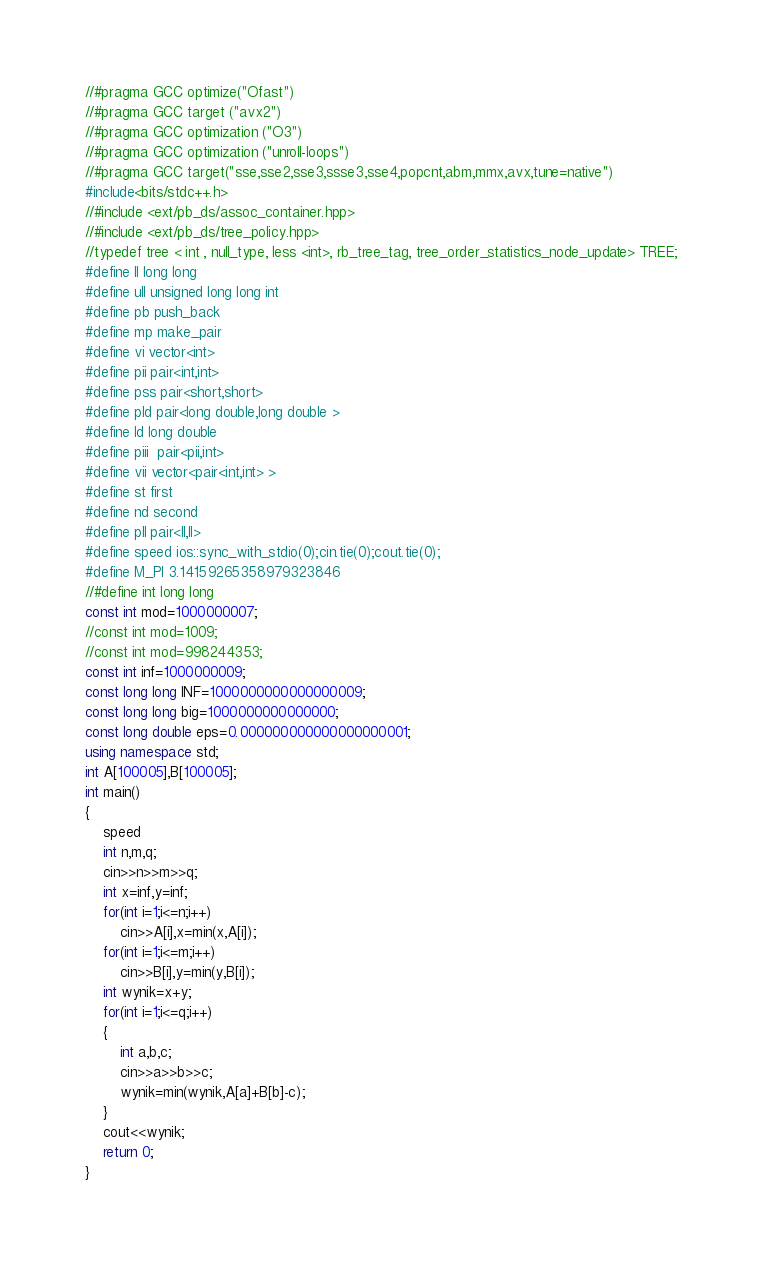<code> <loc_0><loc_0><loc_500><loc_500><_C++_>//#pragma GCC optimize("Ofast")
//#pragma GCC target ("avx2")
//#pragma GCC optimization ("O3")
//#pragma GCC optimization ("unroll-loops")
//#pragma GCC target("sse,sse2,sse3,ssse3,sse4,popcnt,abm,mmx,avx,tune=native")
#include<bits/stdc++.h>
//#include <ext/pb_ds/assoc_container.hpp>
//#include <ext/pb_ds/tree_policy.hpp>
//typedef tree < int , null_type, less <int>, rb_tree_tag, tree_order_statistics_node_update> TREE;
#define ll long long
#define ull unsigned long long int
#define pb push_back
#define mp make_pair
#define vi vector<int>
#define pii pair<int,int>
#define pss pair<short,short>
#define pld pair<long double,long double >
#define ld long double
#define piii  pair<pii,int>
#define vii vector<pair<int,int> >
#define st first
#define nd second
#define pll pair<ll,ll>
#define speed ios::sync_with_stdio(0);cin.tie(0);cout.tie(0);
#define M_PI 3.14159265358979323846
//#define int long long
const int mod=1000000007;
//const int mod=1009;
//const int mod=998244353;
const int inf=1000000009;
const long long INF=1000000000000000009;
const long long big=1000000000000000;
const long double eps=0.000000000000000000001;
using namespace std;
int A[100005],B[100005];
int main()
{
    speed
    int n,m,q;
    cin>>n>>m>>q;
    int x=inf,y=inf;
    for(int i=1;i<=n;i++)
        cin>>A[i],x=min(x,A[i]);
    for(int i=1;i<=m;i++)
        cin>>B[i],y=min(y,B[i]);
    int wynik=x+y;
    for(int i=1;i<=q;i++)
    {
        int a,b,c;
        cin>>a>>b>>c;
        wynik=min(wynik,A[a]+B[b]-c);
    }
    cout<<wynik;
    return 0;
}
</code> 